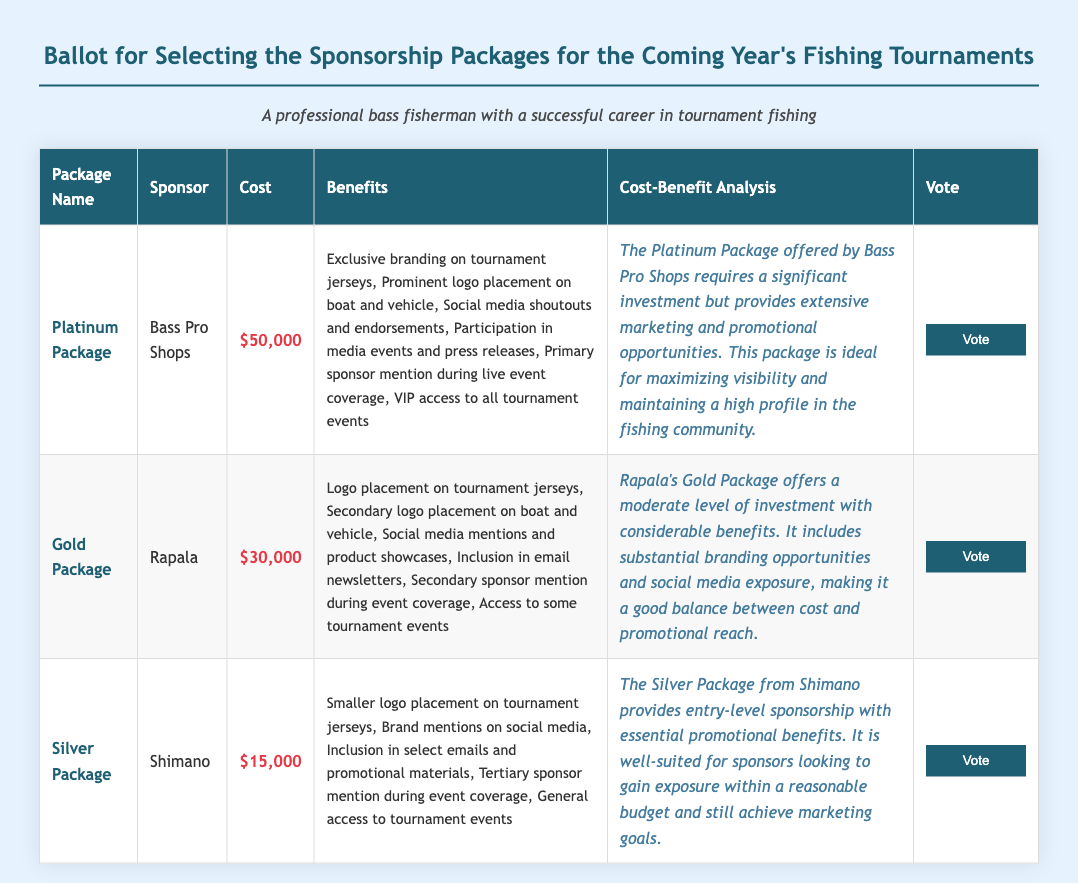What is the cost of the Platinum Package? The cost of the Platinum Package is listed in the document as $50,000.
Answer: $50,000 Who is the sponsor for the Gold Package? The Gold Package is sponsored by Rapala, as mentioned in the document.
Answer: Rapala What benefits are included in the Silver Package? The Silver Package includes benefits such as smaller logo placement on tournament jerseys and brand mentions on social media.
Answer: Smaller logo placement on tournament jerseys, Brand mentions on social media What is the main analysis point for the Gold Package? The main analysis point for the Gold Package speaks about its moderate level of investment with considerable benefits.
Answer: Moderate level of investment with considerable benefits What type of access does the Platinum Package provide? The Platinum Package provides VIP access to all tournament events as specified in the benefits section.
Answer: VIP access to all tournament events How many vote options are available in this document? The document lists three sponsorship packages, each with a vote button.
Answer: Three What is the analysis description for the Platinum Package? The analysis description for the Platinum Package discusses marketing and promotional opportunities and is ideal for maximizing visibility.
Answer: Ideal for maximizing visibility and maintaining a high profile in the fishing community What logo placement opportunity is offered in the Gold Package? The Gold Package offers secondary logo placement on the boat and vehicle according to the benefits section.
Answer: Secondary logo placement on boat and vehicle Which package requires the lowest investment? Among the listed packages, the Silver Package requires the lowest investment of $15,000.
Answer: Silver Package 